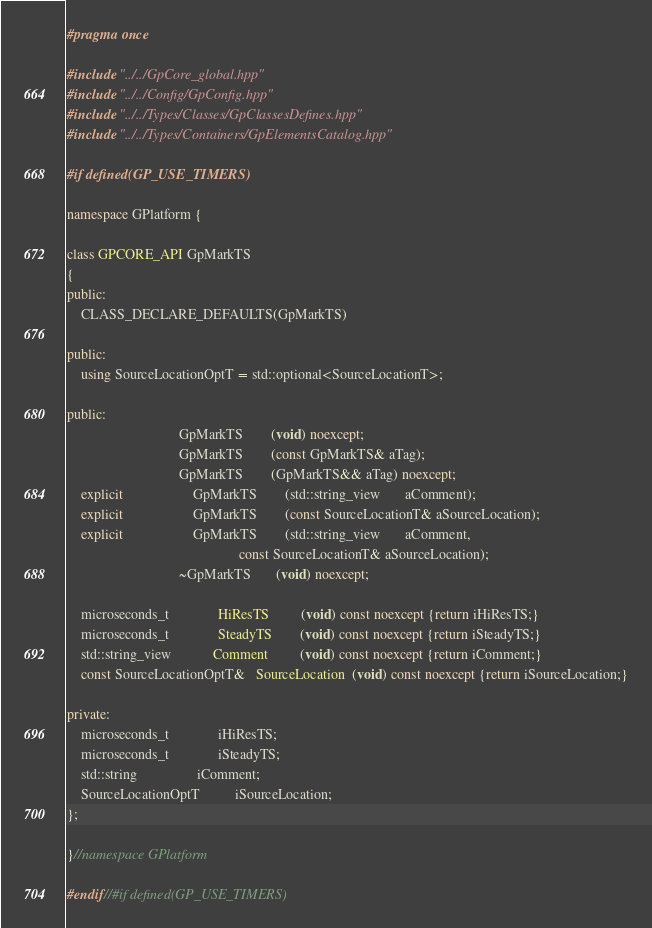<code> <loc_0><loc_0><loc_500><loc_500><_C++_>#pragma once

#include "../../GpCore_global.hpp"
#include "../../Config/GpConfig.hpp"
#include "../../Types/Classes/GpClassesDefines.hpp"
#include "../../Types/Containers/GpElementsCatalog.hpp"

#if defined(GP_USE_TIMERS)

namespace GPlatform {

class GPCORE_API GpMarkTS
{
public:
    CLASS_DECLARE_DEFAULTS(GpMarkTS)

public:
    using SourceLocationOptT = std::optional<SourceLocationT>;

public:
                                GpMarkTS        (void) noexcept;
                                GpMarkTS        (const GpMarkTS& aTag);
                                GpMarkTS        (GpMarkTS&& aTag) noexcept;
    explicit                    GpMarkTS        (std::string_view       aComment);
    explicit                    GpMarkTS        (const SourceLocationT& aSourceLocation);
    explicit                    GpMarkTS        (std::string_view       aComment,
                                                 const SourceLocationT& aSourceLocation);
                                ~GpMarkTS       (void) noexcept;

    microseconds_t              HiResTS         (void) const noexcept {return iHiResTS;}
    microseconds_t              SteadyTS        (void) const noexcept {return iSteadyTS;}
    std::string_view            Comment         (void) const noexcept {return iComment;}
    const SourceLocationOptT&   SourceLocation  (void) const noexcept {return iSourceLocation;}

private:
    microseconds_t              iHiResTS;
    microseconds_t              iSteadyTS;
    std::string                 iComment;
    SourceLocationOptT          iSourceLocation;
};

}//namespace GPlatform

#endif//#if defined(GP_USE_TIMERS)
</code> 